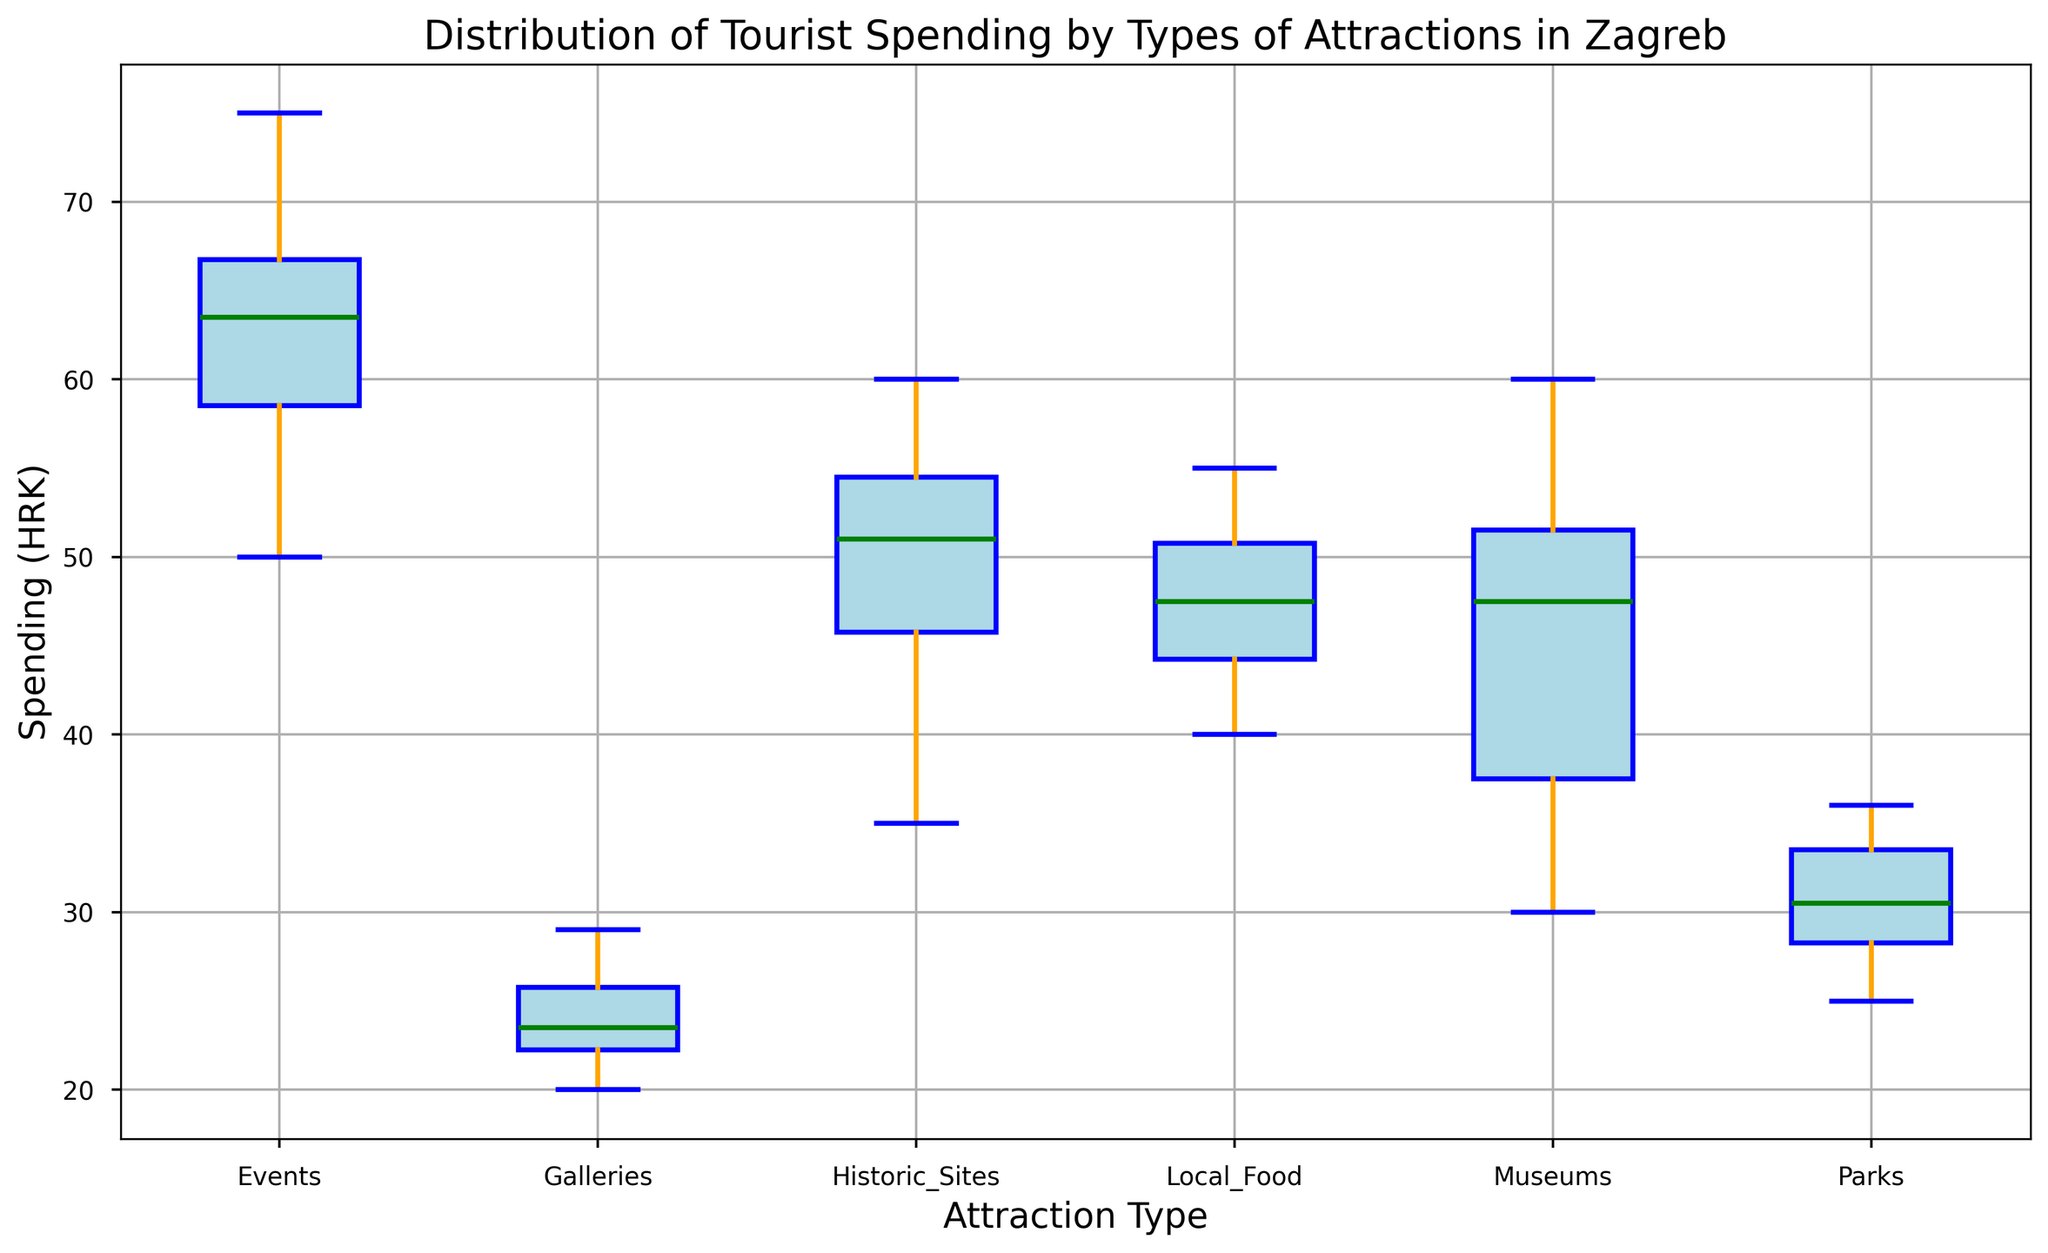What is the median spending for visitors to Museums? To find the median spending for Museums, locate the middle value of spending data points when they are ordered from least to greatest. From the box plot, the median is typically indicated by a horizontal line inside the box.
Answer: 47 HRK Which type of attraction has the highest median spending? By comparing the horizontal lines inside the boxes of each attraction type, we see that the median spending for Events is the highest.
Answer: Events What is the range of spending for Galleries? The range is calculated by subtracting the smallest spending (lower whisker) from the largest spending (upper whisker) for Galleries. From the box plot, find the endpoints of the whiskers.
Answer: 20 HRK to 29 HRK Are there any outliers in the spending data for Parks? Outliers are typically plotted as individual points outside the whiskers of the box plot. Examining the plot for Parks, we do not see any separate points beyond the whiskers.
Answer: No How does the interquartile range (IQR) of Spending for Historic Sites compare to that of Local Food? The IQR is the difference between the third quartile (top of the box) and the first quartile (bottom of the box). Calculate the IQR for both and compare their lengths.
Answer: Historic Sites have a larger IQR Which attraction type has the widest spread of spending? The spread is determined by the length between the smallest and largest values (whiskers) in the plot. Identify the longest whiskers visually.
Answer: Events What is the difference between the median spendings of Museums and Parks? Find the median (middle line in the box) for both Museums and Parks, then subtract the median of Parks from the median of Museums.
Answer: 47 HRK - 30 HRK = 17 HRK Do Museums or Historic Sites have a higher third quartile? The third quartile (Q3) is the top edge of the box. Compare the third quartile lines for Museums and Historic Sites.
Answer: Historic Sites Which attraction type has the smallest variation in spending? Variation can be assessed by the length of the box and whiskers. Shorter boxes and whiskers indicate less variation.
Answer: Galleries Is the median spending for Events more than twice the median spending for Galleries? Compare the median spending lines for both types. For Events, the median is around 63 HRK, and for Galleries, it’s around 24 HRK. Check if 63 is more than twice 24.
Answer: Yes 